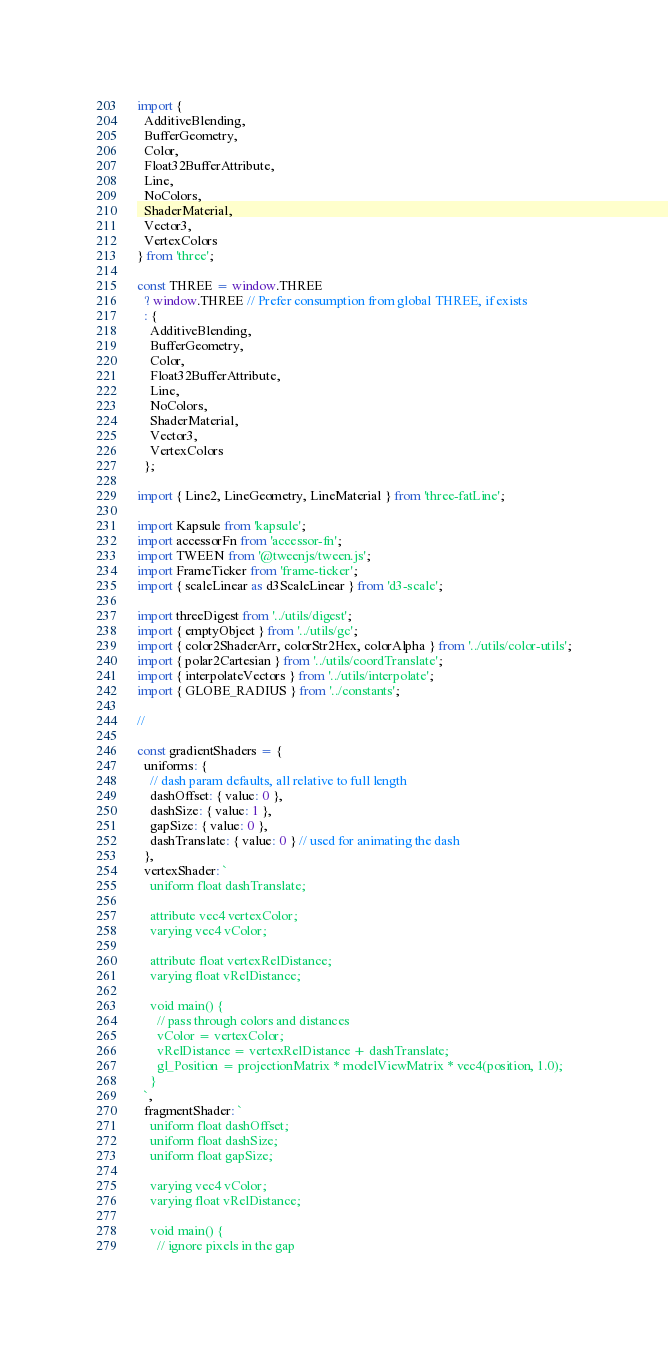<code> <loc_0><loc_0><loc_500><loc_500><_JavaScript_>import {
  AdditiveBlending,
  BufferGeometry,
  Color,
  Float32BufferAttribute,
  Line,
  NoColors,
  ShaderMaterial,
  Vector3,
  VertexColors
} from 'three';

const THREE = window.THREE
  ? window.THREE // Prefer consumption from global THREE, if exists
  : {
    AdditiveBlending,
    BufferGeometry,
    Color,
    Float32BufferAttribute,
    Line,
    NoColors,
    ShaderMaterial,
    Vector3,
    VertexColors
  };

import { Line2, LineGeometry, LineMaterial } from 'three-fatLine';

import Kapsule from 'kapsule';
import accessorFn from 'accessor-fn';
import TWEEN from '@tweenjs/tween.js';
import FrameTicker from 'frame-ticker';
import { scaleLinear as d3ScaleLinear } from 'd3-scale';

import threeDigest from '../utils/digest';
import { emptyObject } from '../utils/gc';
import { color2ShaderArr, colorStr2Hex, colorAlpha } from '../utils/color-utils';
import { polar2Cartesian } from '../utils/coordTranslate';
import { interpolateVectors } from '../utils/interpolate';
import { GLOBE_RADIUS } from '../constants';

//

const gradientShaders = {
  uniforms: {
    // dash param defaults, all relative to full length
    dashOffset: { value: 0 },
    dashSize: { value: 1 },
    gapSize: { value: 0 },
    dashTranslate: { value: 0 } // used for animating the dash
  },
  vertexShader: `
    uniform float dashTranslate;

    attribute vec4 vertexColor;
    varying vec4 vColor;

    attribute float vertexRelDistance;
    varying float vRelDistance;

    void main() {
      // pass through colors and distances
      vColor = vertexColor;
      vRelDistance = vertexRelDistance + dashTranslate;
      gl_Position = projectionMatrix * modelViewMatrix * vec4(position, 1.0);
    }
  `,
  fragmentShader: `
    uniform float dashOffset;
    uniform float dashSize;
    uniform float gapSize;

    varying vec4 vColor;
    varying float vRelDistance;

    void main() {
      // ignore pixels in the gap</code> 